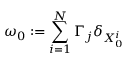<formula> <loc_0><loc_0><loc_500><loc_500>\omega _ { 0 } \colon = \sum _ { i = 1 } ^ { N } \Gamma _ { j } \delta _ { X _ { 0 } ^ { i } }</formula> 